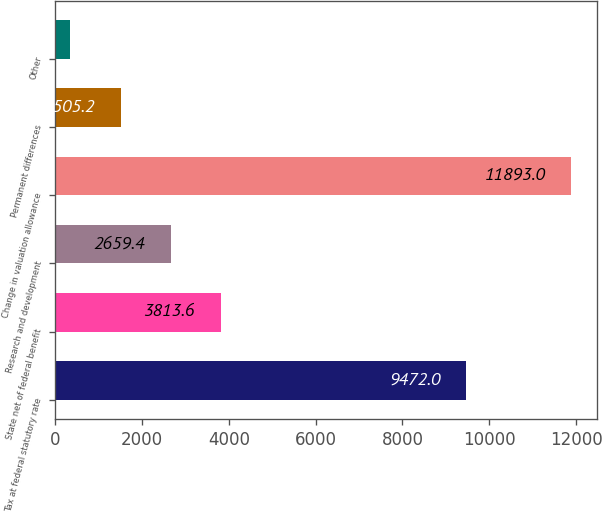<chart> <loc_0><loc_0><loc_500><loc_500><bar_chart><fcel>Tax at federal statutory rate<fcel>State net of federal benefit<fcel>Research and development<fcel>Change in valuation allowance<fcel>Permanent differences<fcel>Other<nl><fcel>9472<fcel>3813.6<fcel>2659.4<fcel>11893<fcel>1505.2<fcel>351<nl></chart> 